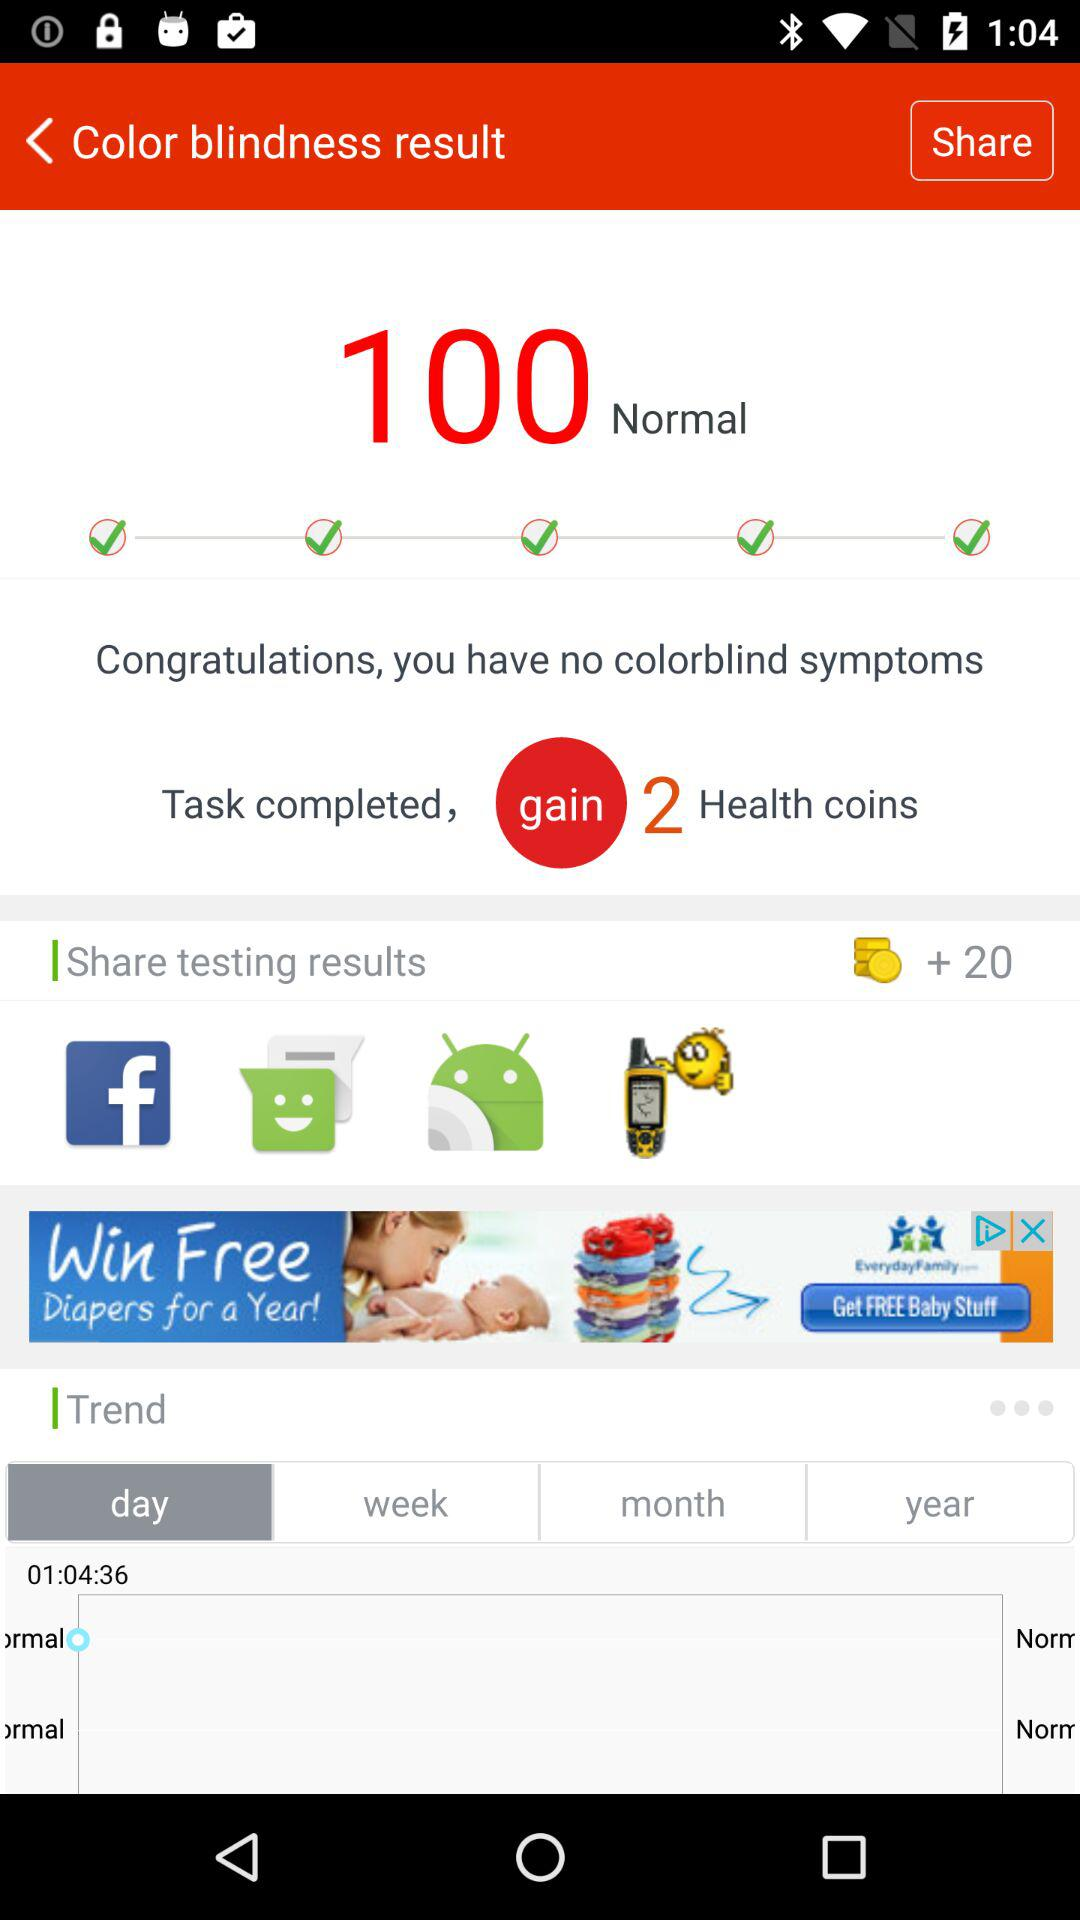Are there any colorblind symptoms? There are no colorblind symptoms. 